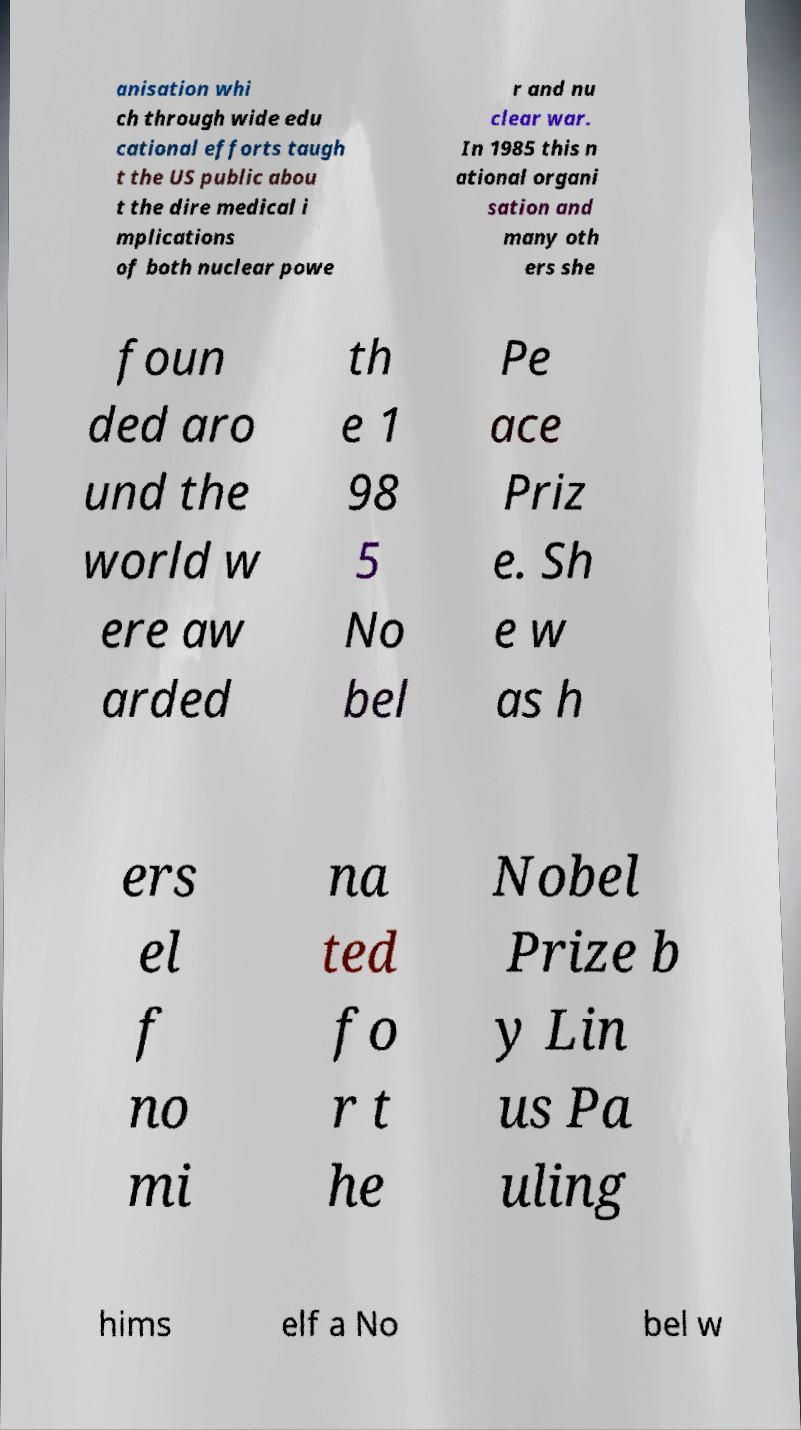Please identify and transcribe the text found in this image. anisation whi ch through wide edu cational efforts taugh t the US public abou t the dire medical i mplications of both nuclear powe r and nu clear war. In 1985 this n ational organi sation and many oth ers she foun ded aro und the world w ere aw arded th e 1 98 5 No bel Pe ace Priz e. Sh e w as h ers el f no mi na ted fo r t he Nobel Prize b y Lin us Pa uling hims elf a No bel w 